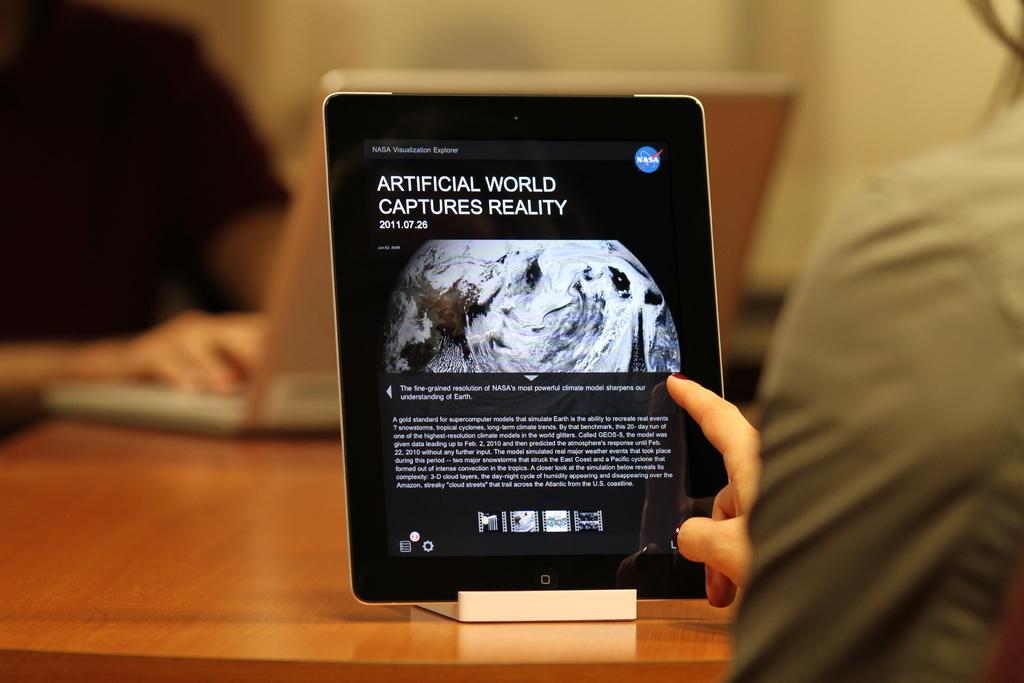How would you summarize this image in a sentence or two? This image consists of a tab in which we can see the text. On the right, there is a person. At the bottom, there is a table. 